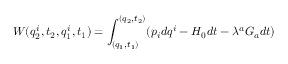<formula> <loc_0><loc_0><loc_500><loc_500>W ( q _ { 2 } ^ { i } , t _ { 2 } , q _ { 1 } ^ { i } , t _ { 1 } ) = \int _ { ( q _ { 1 } , t _ { 1 } ) } ^ { ( q _ { 2 } , t _ { 2 } ) } ( p _ { i } d q ^ { i } - H _ { 0 } d t - \lambda ^ { a } G _ { a } d t )</formula> 